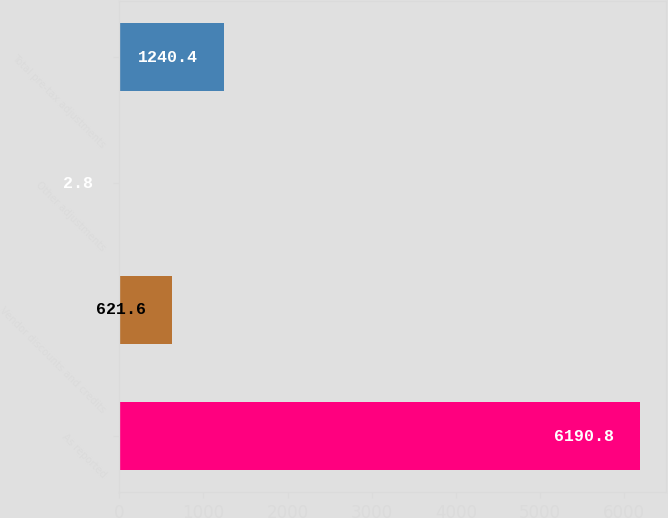Convert chart. <chart><loc_0><loc_0><loc_500><loc_500><bar_chart><fcel>As reported<fcel>Vendor discounts and credits<fcel>Other adjustments<fcel>Total pre-tax adjustments<nl><fcel>6190.8<fcel>621.6<fcel>2.8<fcel>1240.4<nl></chart> 